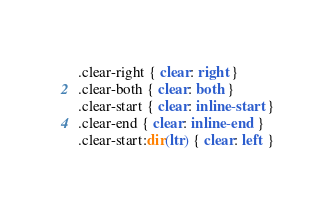<code> <loc_0><loc_0><loc_500><loc_500><_CSS_>.clear-right { clear: right }
.clear-both { clear: both }
.clear-start { clear: inline-start }
.clear-end { clear: inline-end }
.clear-start:dir(ltr) { clear: left }</code> 